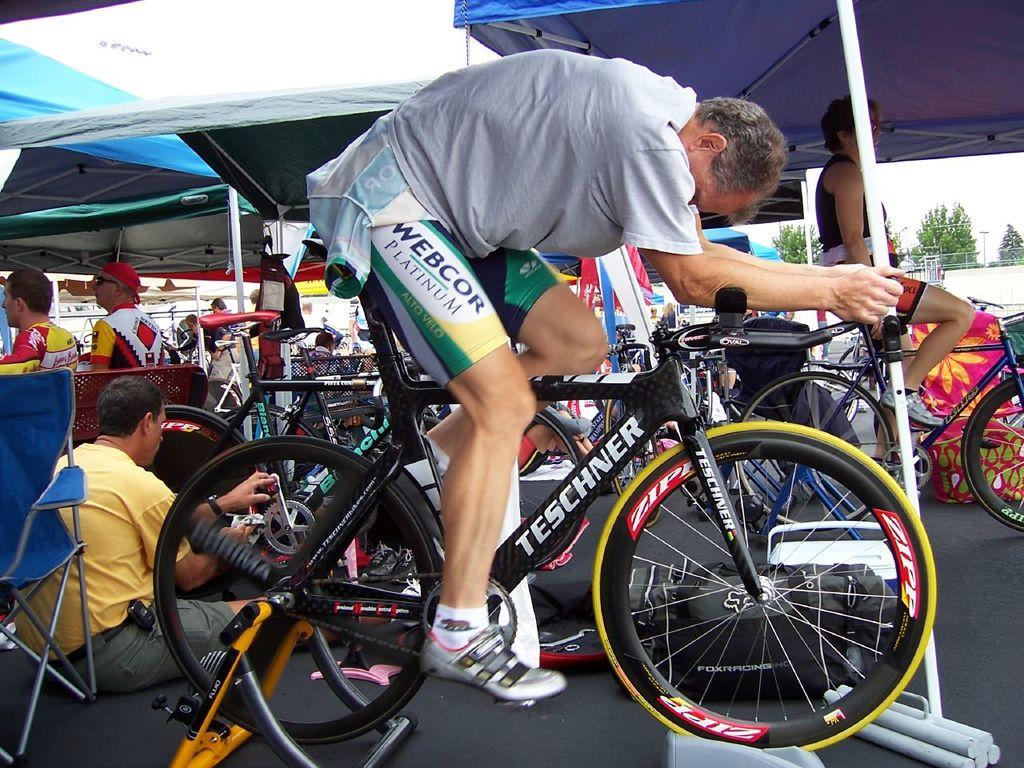What can be seen in the background of the image? There is a sky in the image. Who is present in the image? There are people in the image. What is the man on the left side of the image doing? A man is sitting on a bicycle. What is the position of the man on the right side of the image? Another man is sitting on the floor. What type of toothpaste is the farmer using in the image? There is no toothpaste or farmer present in the image. How many bags can be seen in the image? There are no bags visible in the image. 